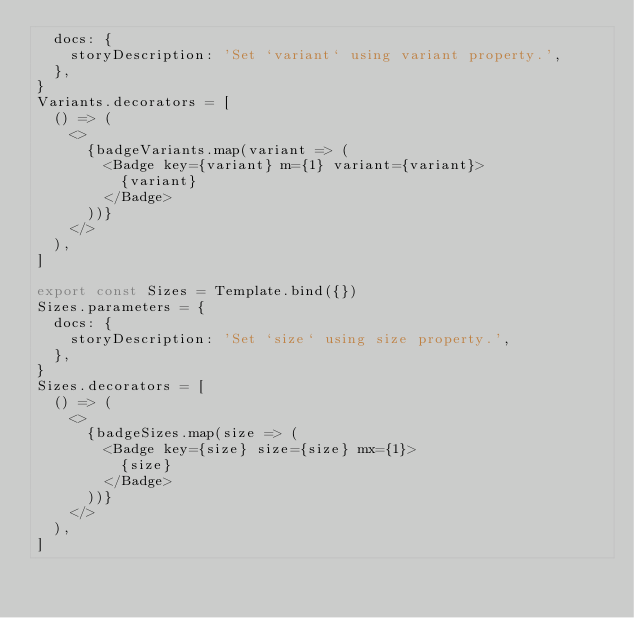Convert code to text. <code><loc_0><loc_0><loc_500><loc_500><_TypeScript_>  docs: {
    storyDescription: 'Set `variant` using variant property.',
  },
}
Variants.decorators = [
  () => (
    <>
      {badgeVariants.map(variant => (
        <Badge key={variant} m={1} variant={variant}>
          {variant}
        </Badge>
      ))}
    </>
  ),
]

export const Sizes = Template.bind({})
Sizes.parameters = {
  docs: {
    storyDescription: 'Set `size` using size property.',
  },
}
Sizes.decorators = [
  () => (
    <>
      {badgeSizes.map(size => (
        <Badge key={size} size={size} mx={1}>
          {size}
        </Badge>
      ))}
    </>
  ),
]
</code> 